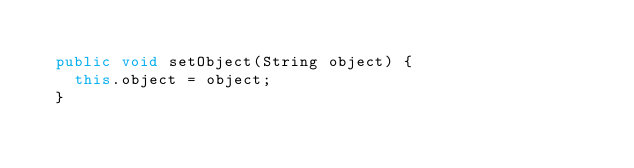<code> <loc_0><loc_0><loc_500><loc_500><_Java_>
	public void setObject(String object) {
		this.object = object;
	}
</code> 